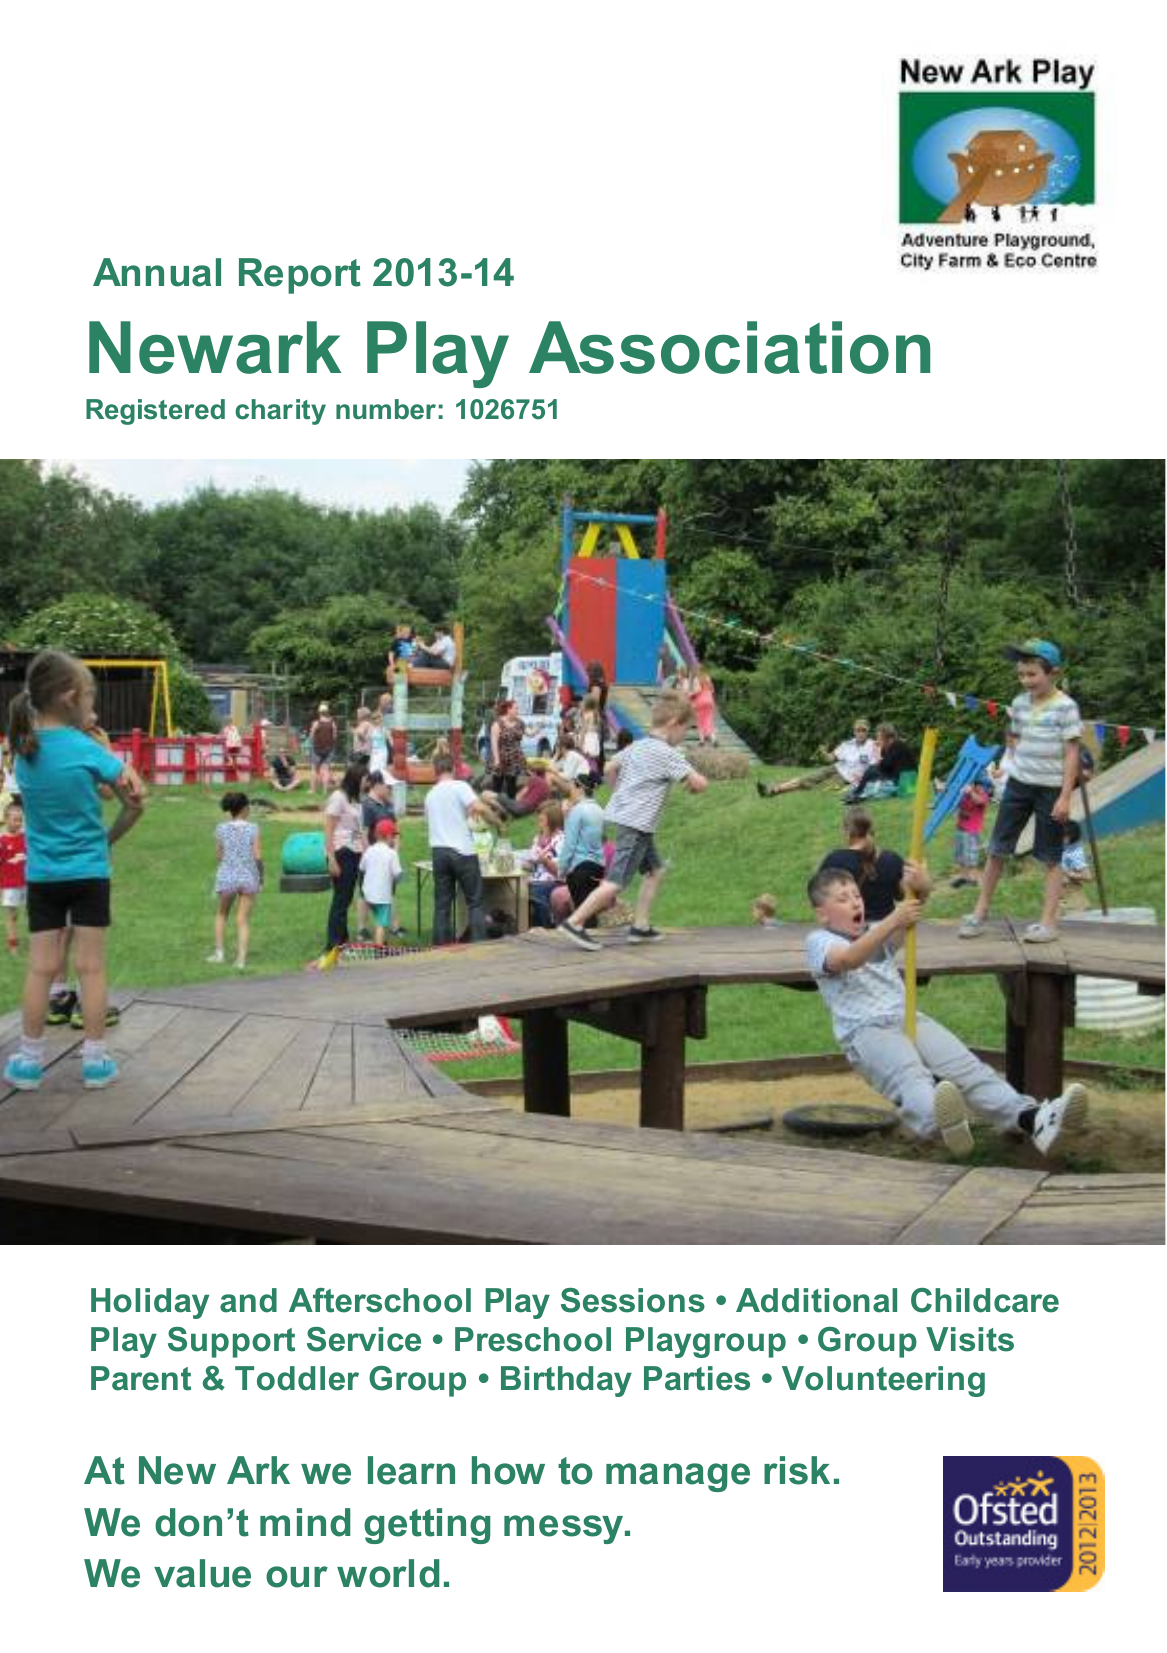What is the value for the report_date?
Answer the question using a single word or phrase. 2014-03-31 